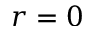<formula> <loc_0><loc_0><loc_500><loc_500>r = 0</formula> 